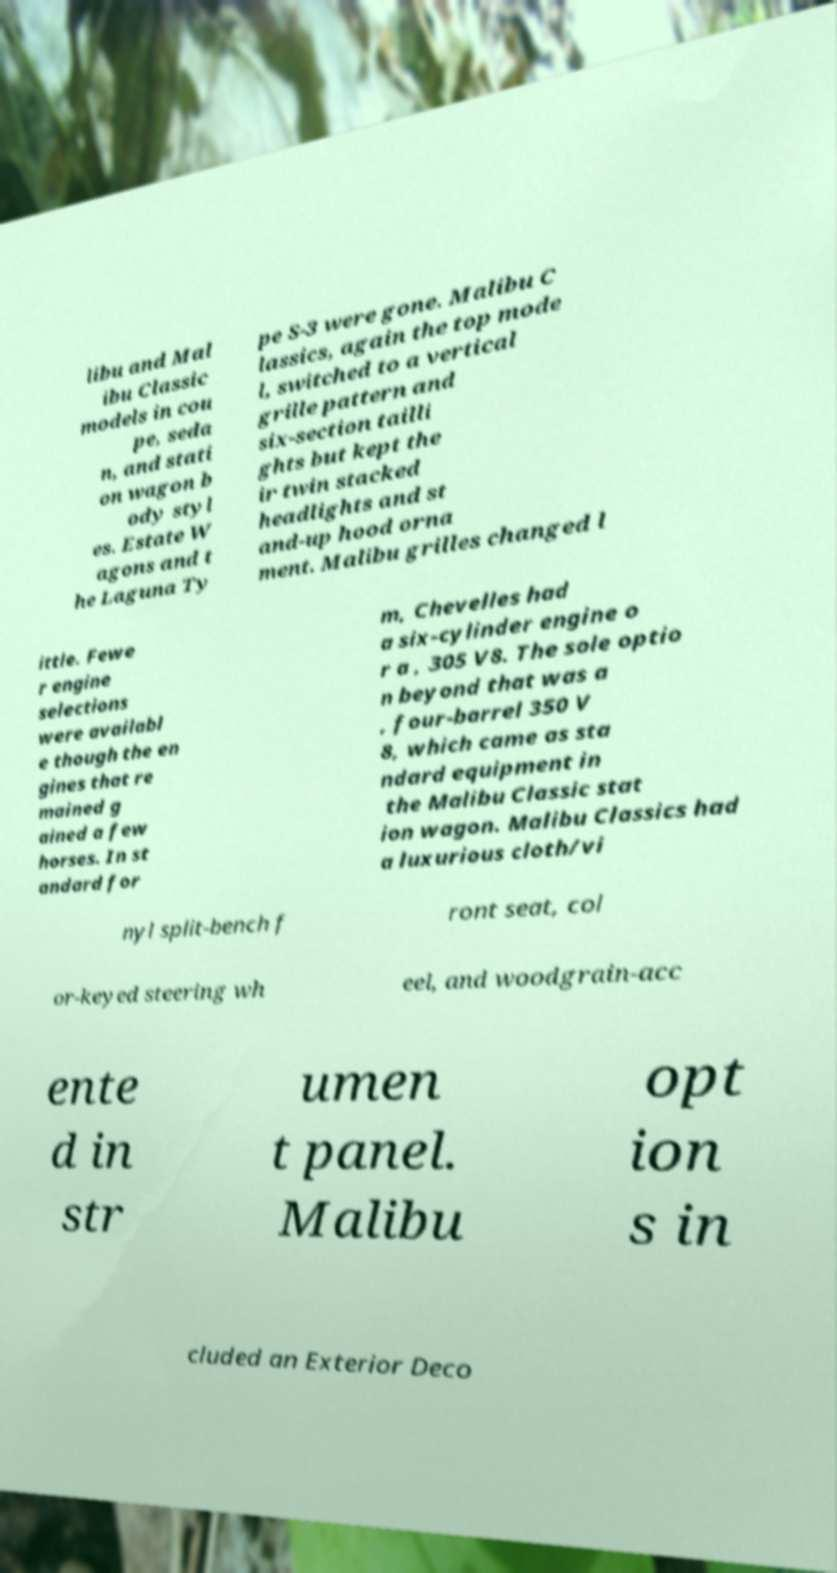Please read and relay the text visible in this image. What does it say? libu and Mal ibu Classic models in cou pe, seda n, and stati on wagon b ody styl es. Estate W agons and t he Laguna Ty pe S-3 were gone. Malibu C lassics, again the top mode l, switched to a vertical grille pattern and six-section tailli ghts but kept the ir twin stacked headlights and st and-up hood orna ment. Malibu grilles changed l ittle. Fewe r engine selections were availabl e though the en gines that re mained g ained a few horses. In st andard for m, Chevelles had a six-cylinder engine o r a , 305 V8. The sole optio n beyond that was a , four-barrel 350 V 8, which came as sta ndard equipment in the Malibu Classic stat ion wagon. Malibu Classics had a luxurious cloth/vi nyl split-bench f ront seat, col or-keyed steering wh eel, and woodgrain-acc ente d in str umen t panel. Malibu opt ion s in cluded an Exterior Deco 